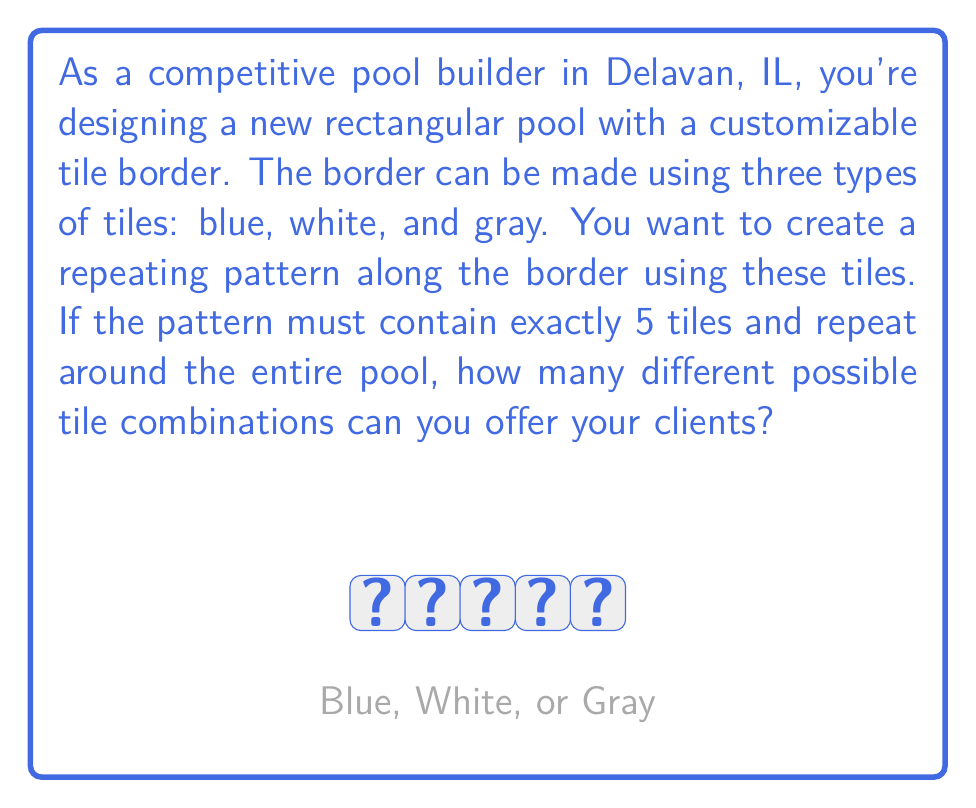What is the answer to this math problem? Let's approach this step-by-step:

1) We are dealing with a combination problem where order matters (as it's a pattern) and repetition is allowed (tiles can be used multiple times).

2) For each position in the 5-tile pattern, we have 3 choices (blue, white, or gray).

3) This scenario can be represented mathematically as follows:
   $$ \text{Number of combinations} = n^r $$
   Where:
   $n$ = number of choices for each position (3 in this case)
   $r$ = number of positions to fill (5 in this case)

4) Plugging in our values:
   $$ \text{Number of combinations} = 3^5 $$

5) Calculate:
   $$ 3^5 = 3 \times 3 \times 3 \times 3 \times 3 = 243 $$

Therefore, you can offer your clients 243 different tile combinations for the pool border.
Answer: 243 